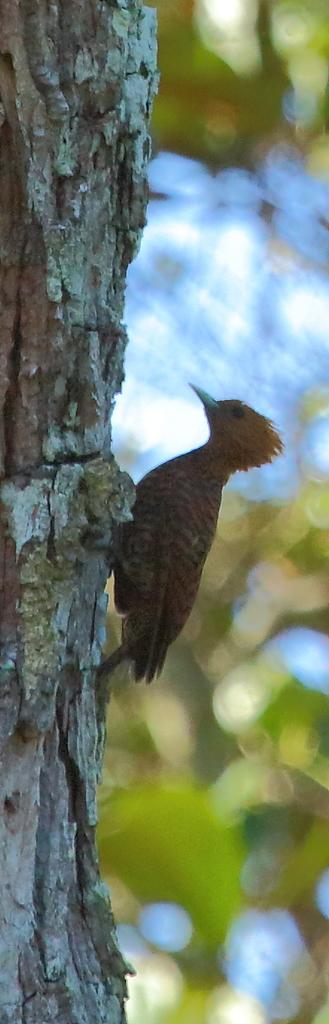What type of animal is in the image? There is a bird in the image. Where is the bird located? The bird is on a tree trunk. Can you describe the background of the image? The background of the image is blurry. What type of jam is the bird spreading on the girls' faces in the image? There is no jam, girls, or spreading activity present in the image; it features a bird on a tree trunk with a blurry background. 